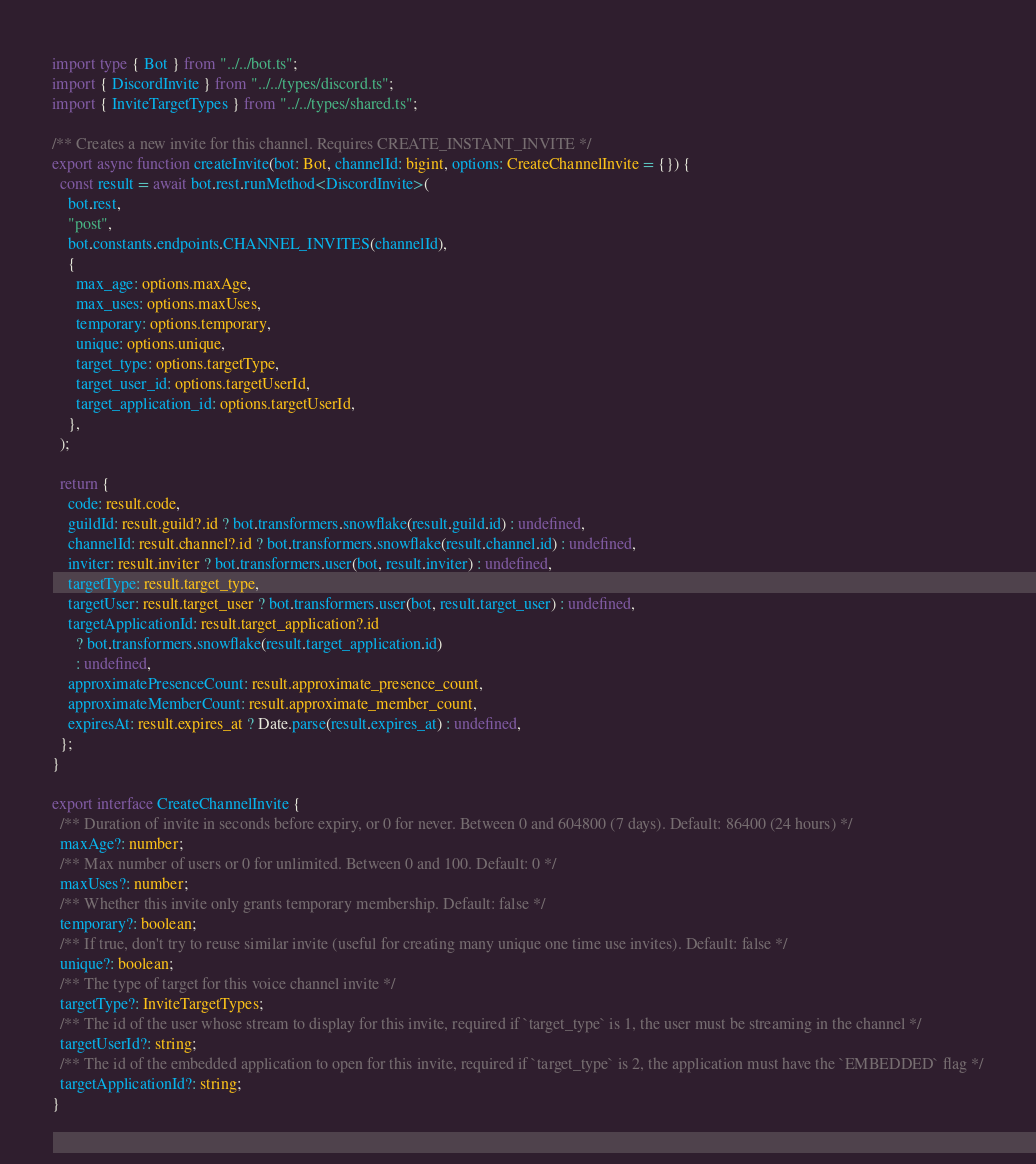Convert code to text. <code><loc_0><loc_0><loc_500><loc_500><_TypeScript_>import type { Bot } from "../../bot.ts";
import { DiscordInvite } from "../../types/discord.ts";
import { InviteTargetTypes } from "../../types/shared.ts";

/** Creates a new invite for this channel. Requires CREATE_INSTANT_INVITE */
export async function createInvite(bot: Bot, channelId: bigint, options: CreateChannelInvite = {}) {
  const result = await bot.rest.runMethod<DiscordInvite>(
    bot.rest,
    "post",
    bot.constants.endpoints.CHANNEL_INVITES(channelId),
    {
      max_age: options.maxAge,
      max_uses: options.maxUses,
      temporary: options.temporary,
      unique: options.unique,
      target_type: options.targetType,
      target_user_id: options.targetUserId,
      target_application_id: options.targetUserId,
    },
  );

  return {
    code: result.code,
    guildId: result.guild?.id ? bot.transformers.snowflake(result.guild.id) : undefined,
    channelId: result.channel?.id ? bot.transformers.snowflake(result.channel.id) : undefined,
    inviter: result.inviter ? bot.transformers.user(bot, result.inviter) : undefined,
    targetType: result.target_type,
    targetUser: result.target_user ? bot.transformers.user(bot, result.target_user) : undefined,
    targetApplicationId: result.target_application?.id
      ? bot.transformers.snowflake(result.target_application.id)
      : undefined,
    approximatePresenceCount: result.approximate_presence_count,
    approximateMemberCount: result.approximate_member_count,
    expiresAt: result.expires_at ? Date.parse(result.expires_at) : undefined,
  };
}

export interface CreateChannelInvite {
  /** Duration of invite in seconds before expiry, or 0 for never. Between 0 and 604800 (7 days). Default: 86400 (24 hours) */
  maxAge?: number;
  /** Max number of users or 0 for unlimited. Between 0 and 100. Default: 0 */
  maxUses?: number;
  /** Whether this invite only grants temporary membership. Default: false */
  temporary?: boolean;
  /** If true, don't try to reuse similar invite (useful for creating many unique one time use invites). Default: false */
  unique?: boolean;
  /** The type of target for this voice channel invite */
  targetType?: InviteTargetTypes;
  /** The id of the user whose stream to display for this invite, required if `target_type` is 1, the user must be streaming in the channel */
  targetUserId?: string;
  /** The id of the embedded application to open for this invite, required if `target_type` is 2, the application must have the `EMBEDDED` flag */
  targetApplicationId?: string;
}
</code> 